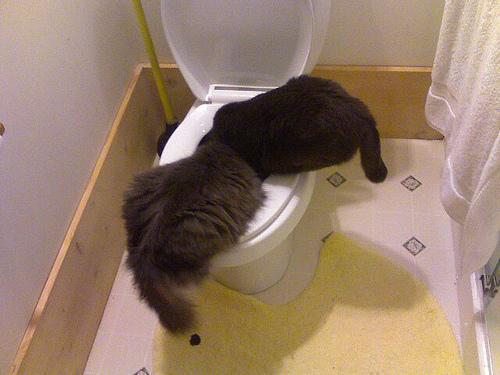How many animals are there?
Give a very brief answer. 2. 